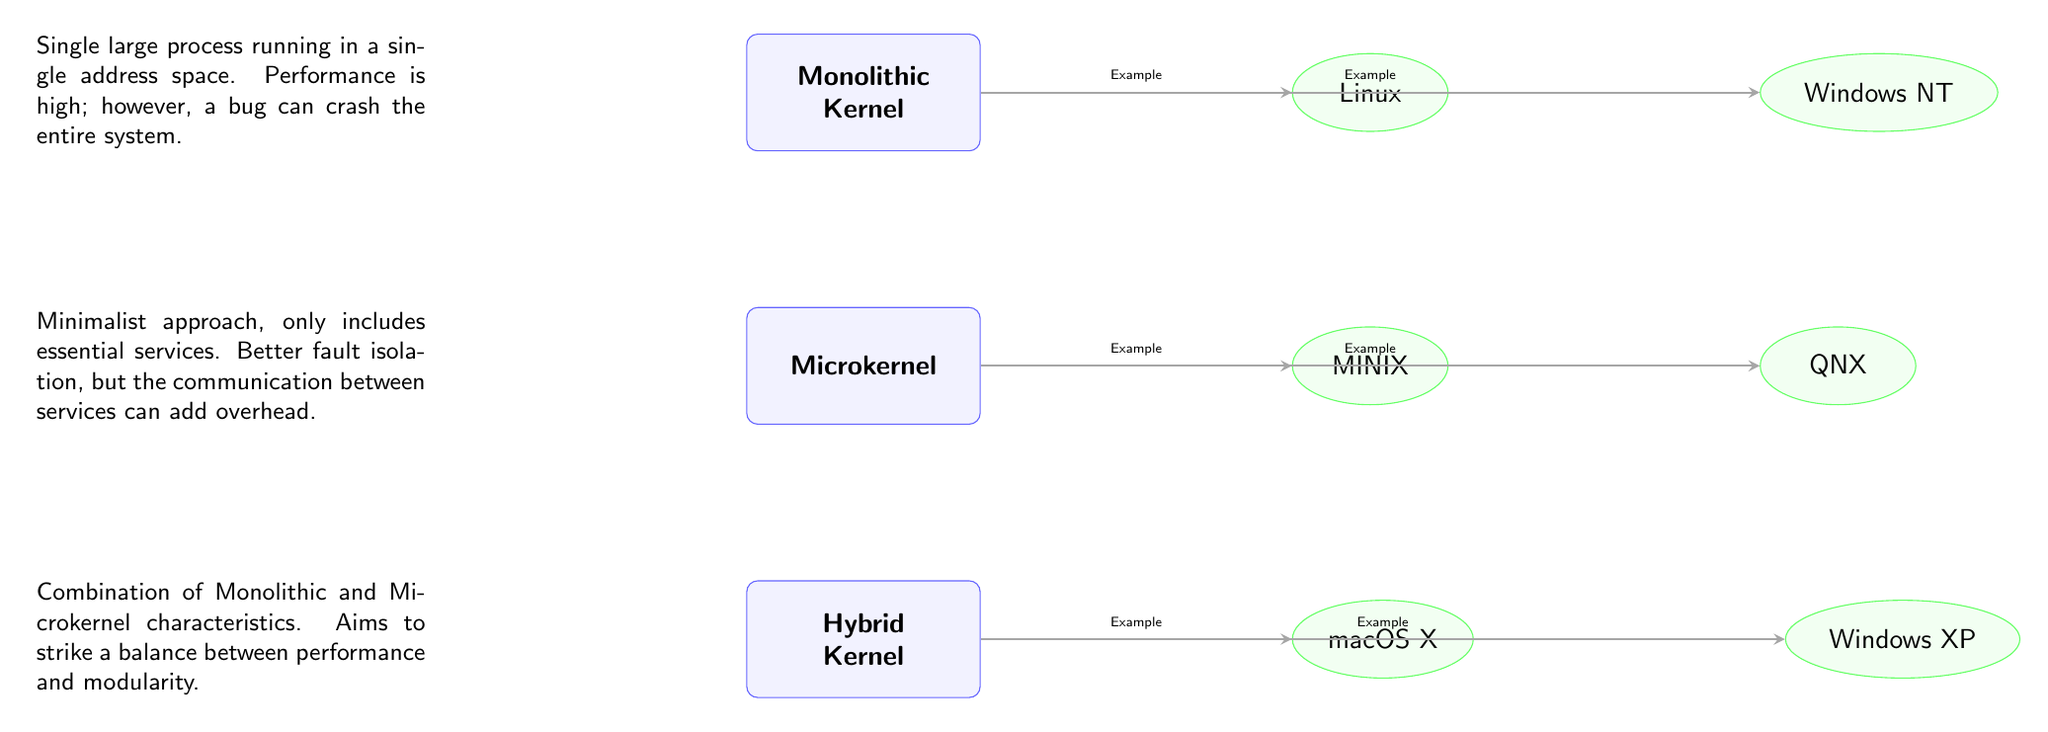What types of kernels are compared in the diagram? The diagram presents three types of kernels: Monolithic Kernel, Microkernel, and Hybrid Kernel. These are displayed as distinct nodes in the diagram, making it easy to identify them visually.
Answer: Monolithic Kernel, Microkernel, Hybrid Kernel Which operating system is an example of a Microkernel? The Microkernel node in the diagram points to MINIX as an example of a Microkernel. The relationship is indicated by an arrow connecting these two nodes.
Answer: MINIX How many operating systems in total are listed in the diagram? There are six operating systems listed: Linux, Windows NT, MINIX, QNX, macOS X, and Windows XP. By counting the instances of the OS nodes connected to the kernel types, we find this total.
Answer: 6 Which kernel type emphasizes fault isolation? The Microkernel is described in the diagram as focusing on a minimalist approach that includes better fault isolation. This characteristic is highlighted in the textual description adjacent to the Microkernel node.
Answer: Microkernel What does the Hybrid Kernel aim to balance? The description next to the Hybrid Kernel in the diagram states that it aims to strike a balance between performance and modularity. This phrase captures the essence of its design philosophy.
Answer: Performance and modularity Which kernel architecture includes essential services only? The Microkernel is identified in the diagram as the architecture that includes only essential services. This information is stated in the description associated with the Microkernel node.
Answer: Microkernel How are Monolithic and Hybrid Kernels related in terms of design features? The diagram shows that the Hybrid Kernel combines characteristics of both Monolithic and Microkernel architectures, as specified in its description. This highlights their interrelationship and the intention behind the Hybrid design.
Answer: Combination of Monolithic and Microkernel characteristics What is a key disadvantage mentioned for Monolithic Kernels? The downside of Monolithic Kernels highlighted in the diagram is that a bug can crash the entire system. This is mentioned directly in the description next to the Monolithic Kernel node.
Answer: A bug can crash the entire system Which operating system is listed as an example of Hybrid Kernel? The diagram indicates that macOS X is an example of a Hybrid Kernel, as it is connected to the Hybrid Kernel node with an arrow.
Answer: macOS X 